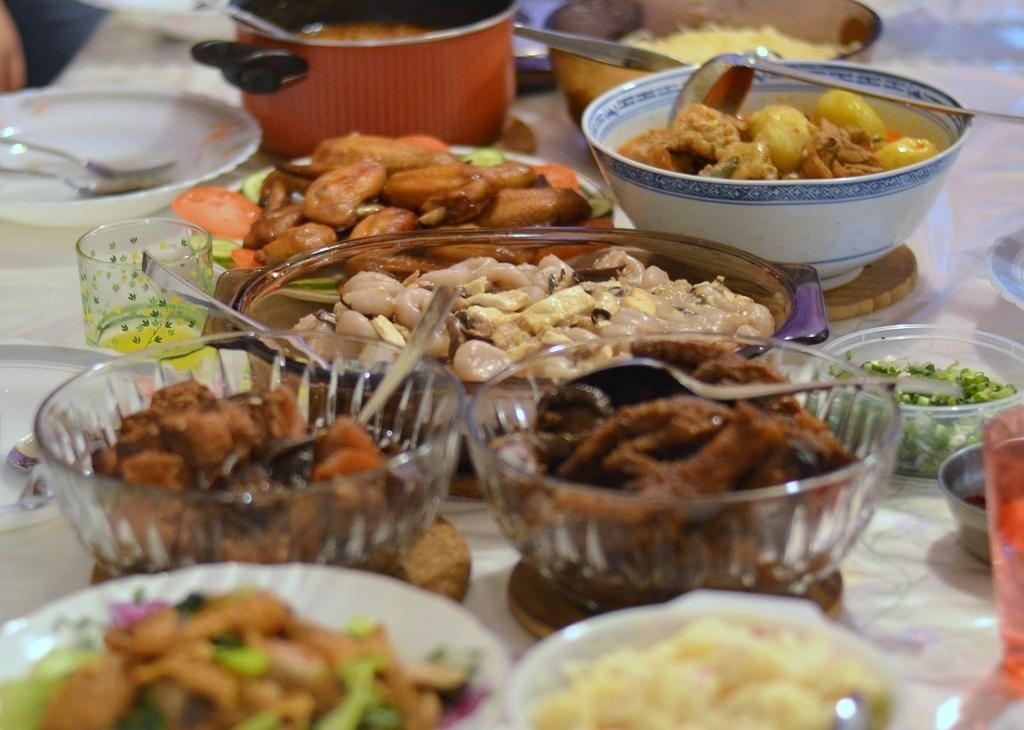What is located at the bottom of the image? There is a table at the bottom of the image. What can be found on the table? There are bowls, spoons, plates, forks, and glasses on the table. What is inside the bowls? The bowls contain food. What utensils are available for eating the food? There are spoons and forks on the table. What might be used for drinking in the image? There are glasses on the table. How many grapes are visible on the table in the image? There is no mention of grapes in the image, so it is impossible to determine how many grapes are visible. 